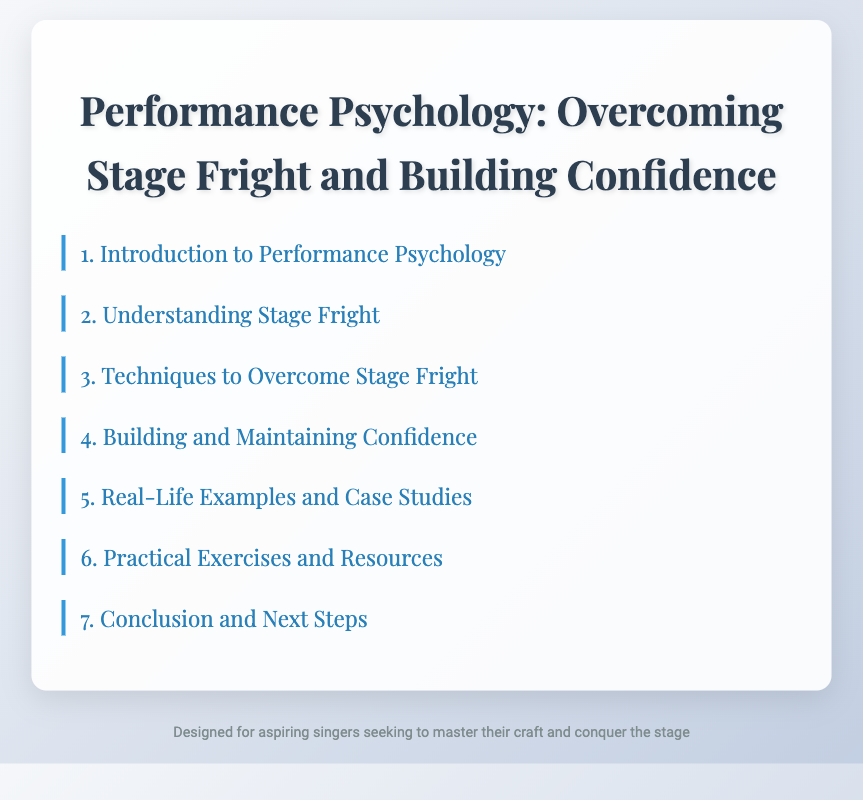what is the title of the document? The title of the document can be found at the top of the rendered page.
Answer: Performance Psychology: Overcoming Stage Fright and Building Confidence how many chapters are there in the document? The number of chapters can be counted from the table of contents listed in the document.
Answer: 7 what is one technique to overcome stage fright mentioned? This information can be found in the sections under Chapter 3, which lists various techniques.
Answer: Breathing Techniques and Vocal Warm-ups what type of resources does Chapter 6 provide? Chapter 6 includes practical exercises and additional resources for singers.
Answer: Daily Confidence-building Exercises who is interviewed in Chapter 5? The section in Chapter 5 mentions individuals who have experience with overcoming stage fright.
Answer: Famous Soloists what is discussed in Chapter 4? The content in Chapter 4 is focused on developing and maintaining a specific quality important for singers.
Answer: Building and Maintaining Confidence how many sections are listed under Chapter 2? This can be determined by looking at the number of bullet points under Chapter 2 in the table of contents.
Answer: 2 what is a key point discussed in the conclusion? The conclusion summarizes important concepts and encourages further action in a personal context.
Answer: Developing a Personal Action Plan 